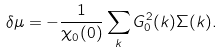Convert formula to latex. <formula><loc_0><loc_0><loc_500><loc_500>\delta \mu = - \frac { 1 } { \chi _ { 0 } ( 0 ) } \sum _ { k } G ^ { 2 } _ { 0 } ( k ) \Sigma ( k ) .</formula> 